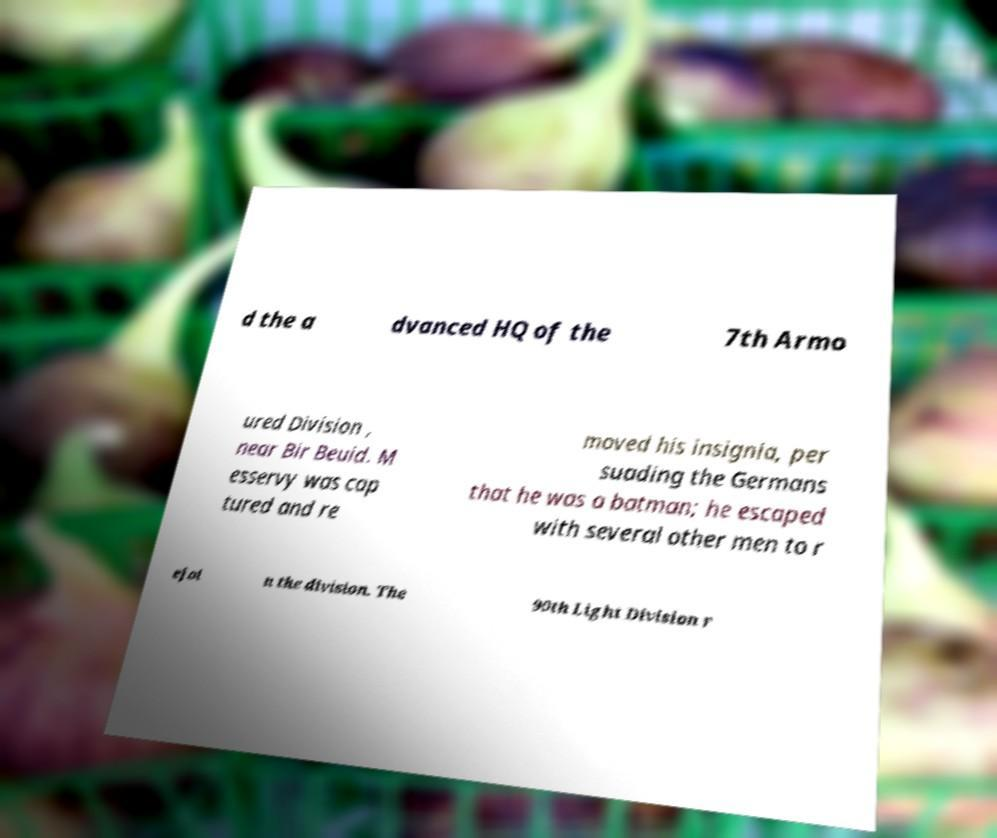For documentation purposes, I need the text within this image transcribed. Could you provide that? d the a dvanced HQ of the 7th Armo ured Division , near Bir Beuid. M esservy was cap tured and re moved his insignia, per suading the Germans that he was a batman; he escaped with several other men to r ejoi n the division. The 90th Light Division r 